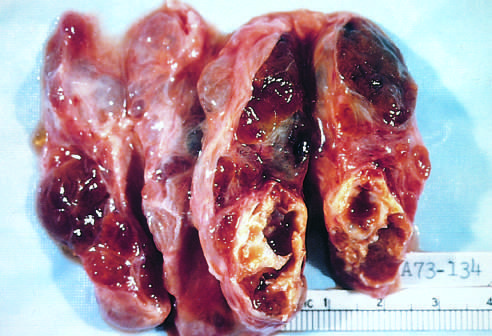the hyperplastic follicles contain abundant pink colloid within whose lumina?
Answer the question using a single word or phrase. Their 